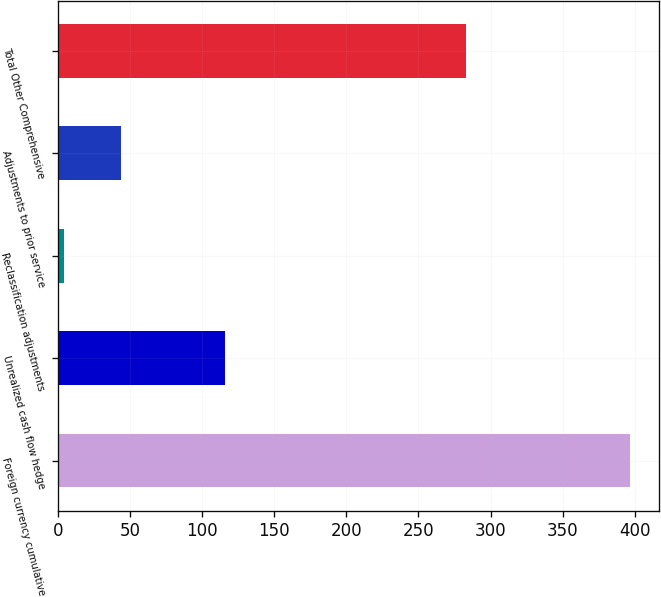Convert chart to OTSL. <chart><loc_0><loc_0><loc_500><loc_500><bar_chart><fcel>Foreign currency cumulative<fcel>Unrealized cash flow hedge<fcel>Reclassification adjustments<fcel>Adjustments to prior service<fcel>Total Other Comprehensive<nl><fcel>396.8<fcel>116<fcel>4.6<fcel>43.82<fcel>282.8<nl></chart> 